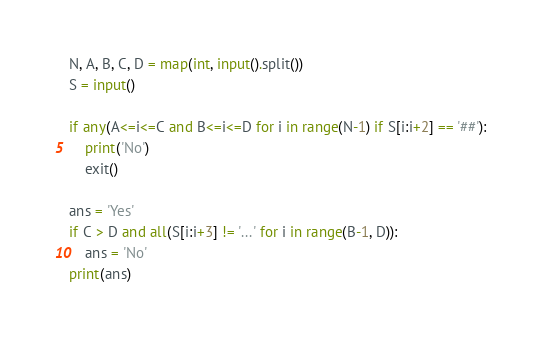Convert code to text. <code><loc_0><loc_0><loc_500><loc_500><_Python_>N, A, B, C, D = map(int, input().split())
S = input()

if any(A<=i<=C and B<=i<=D for i in range(N-1) if S[i:i+2] == '##'):
    print('No')
    exit()

ans = 'Yes'
if C > D and all(S[i:i+3] != '...' for i in range(B-1, D)):
    ans = 'No'
print(ans)
</code> 